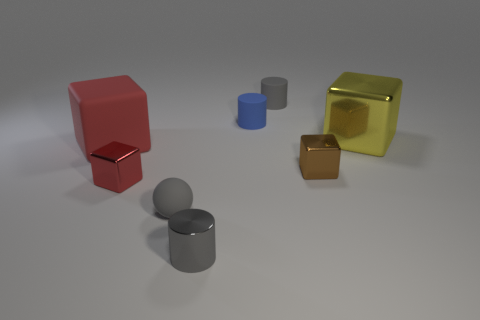Is the color of the tiny ball the same as the small shiny cylinder?
Your answer should be compact. Yes. There is a brown thing that is made of the same material as the tiny red thing; what size is it?
Provide a short and direct response. Small. How many other small metal cylinders are the same color as the metallic cylinder?
Ensure brevity in your answer.  0. Does the cylinder in front of the small red thing have the same color as the tiny matte sphere?
Your response must be concise. Yes. Are there the same number of large shiny blocks that are left of the red matte cube and large yellow objects left of the small blue cylinder?
Offer a terse response. Yes. Are there any other things that have the same material as the yellow object?
Provide a short and direct response. Yes. There is a small cylinder in front of the large yellow object; what is its color?
Make the answer very short. Gray. Is the number of brown metal cubes that are behind the tiny shiny cylinder the same as the number of small red metallic objects?
Offer a terse response. Yes. How many other things are there of the same shape as the big red matte thing?
Your answer should be very brief. 3. What number of red objects are in front of the large rubber object?
Your answer should be very brief. 1. 